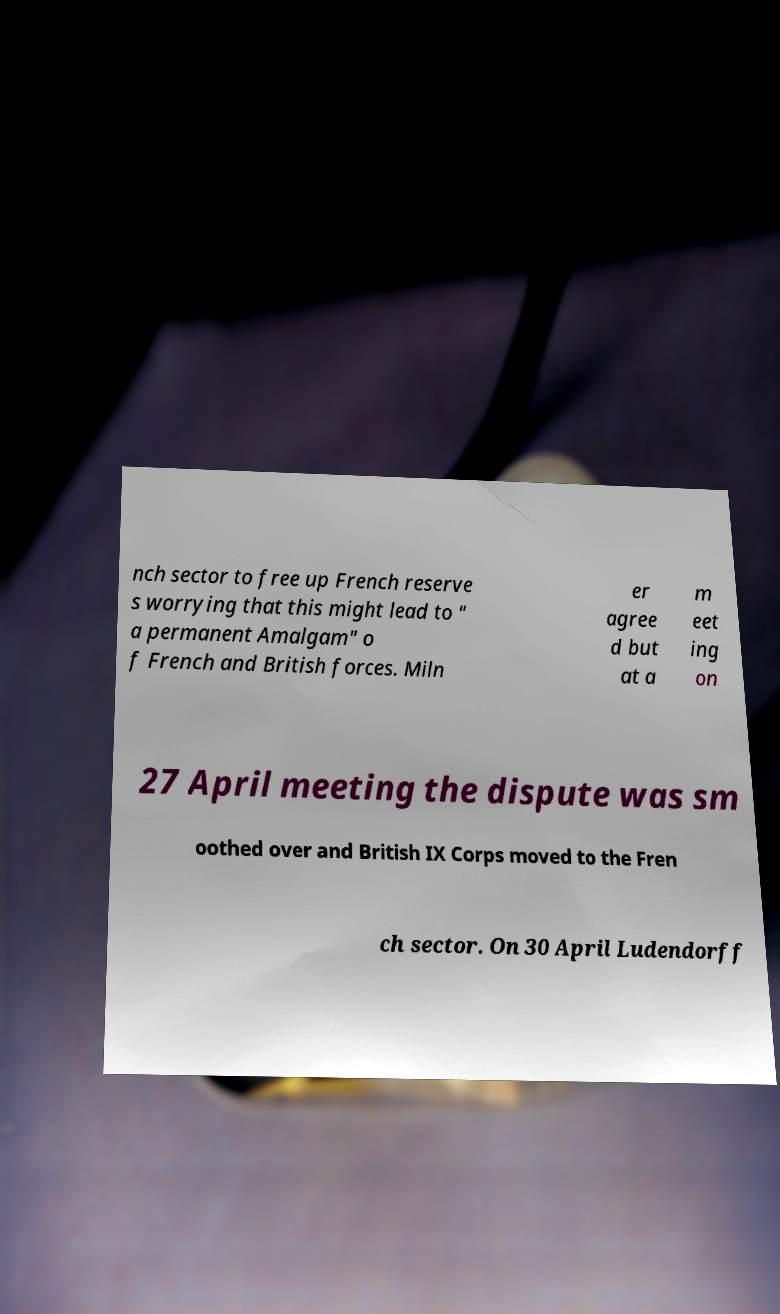Please read and relay the text visible in this image. What does it say? nch sector to free up French reserve s worrying that this might lead to " a permanent Amalgam" o f French and British forces. Miln er agree d but at a m eet ing on 27 April meeting the dispute was sm oothed over and British IX Corps moved to the Fren ch sector. On 30 April Ludendorff 